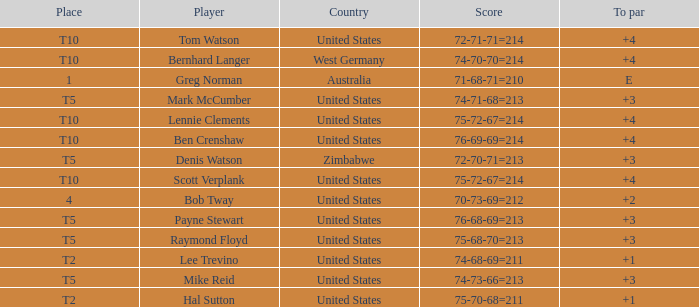What is player raymond floyd's country? United States. 